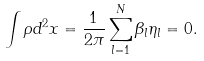<formula> <loc_0><loc_0><loc_500><loc_500>\int \rho d ^ { 2 } x = \frac { 1 } { 2 \pi } \sum _ { l = 1 } ^ { N } \beta _ { l } \eta _ { l } = 0 .</formula> 